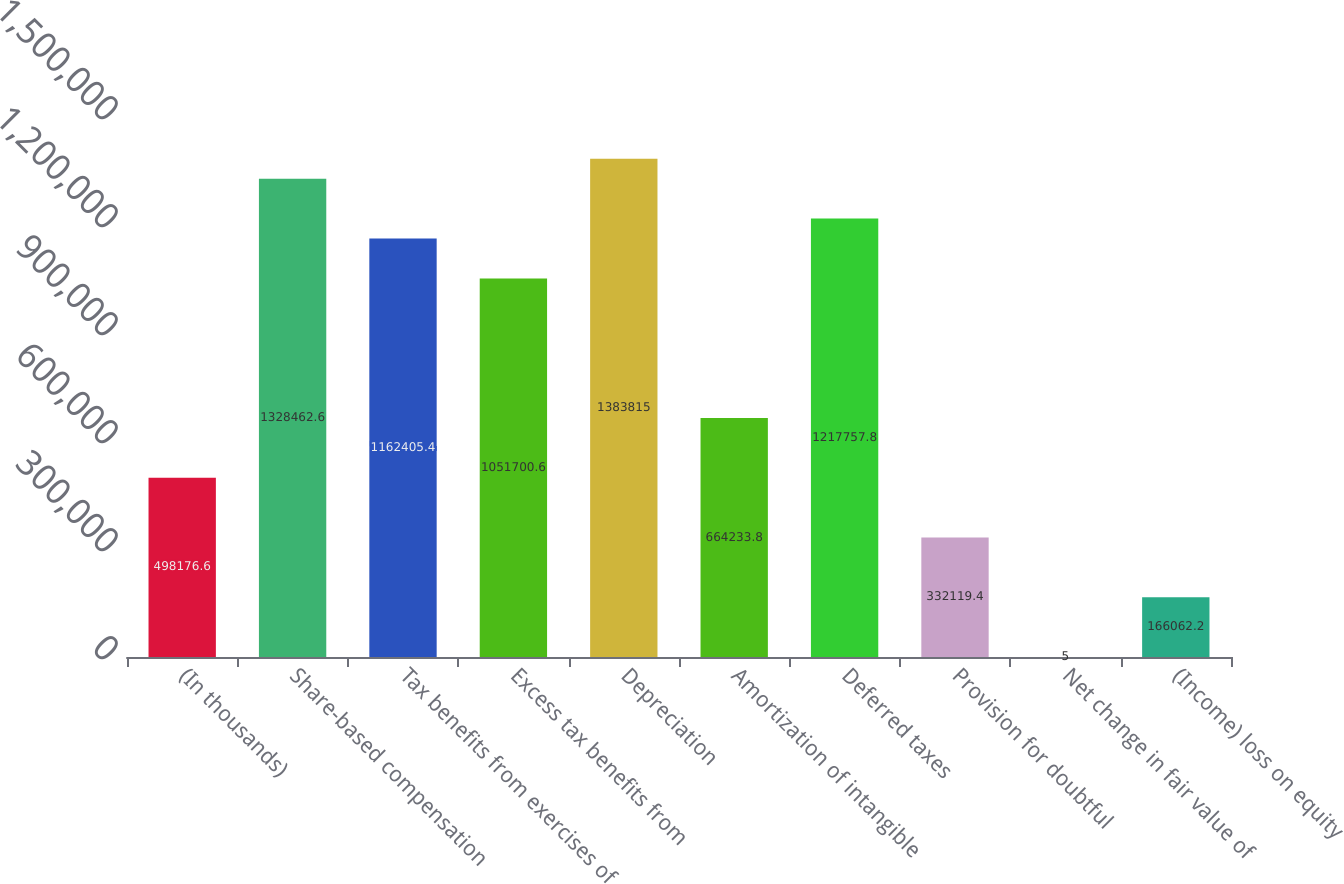Convert chart. <chart><loc_0><loc_0><loc_500><loc_500><bar_chart><fcel>(In thousands)<fcel>Share-based compensation<fcel>Tax benefits from exercises of<fcel>Excess tax benefits from<fcel>Depreciation<fcel>Amortization of intangible<fcel>Deferred taxes<fcel>Provision for doubtful<fcel>Net change in fair value of<fcel>(Income) loss on equity<nl><fcel>498177<fcel>1.32846e+06<fcel>1.16241e+06<fcel>1.0517e+06<fcel>1.38382e+06<fcel>664234<fcel>1.21776e+06<fcel>332119<fcel>5<fcel>166062<nl></chart> 